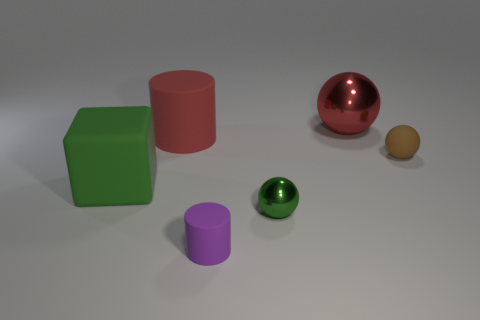There is a ball to the right of the large thing right of the tiny matte cylinder; what number of tiny brown matte spheres are right of it?
Make the answer very short. 0. What number of big metallic objects are the same shape as the purple matte object?
Provide a succinct answer. 0. There is a tiny thing that is behind the large block; is its color the same as the matte block?
Keep it short and to the point. No. There is a rubber object on the left side of the rubber cylinder that is behind the tiny matte cylinder in front of the big red matte cylinder; what is its shape?
Your answer should be very brief. Cube. There is a red shiny object; is its size the same as the matte cylinder behind the small matte cylinder?
Keep it short and to the point. Yes. Are there any blue cubes that have the same size as the green sphere?
Offer a terse response. No. How many other things are there of the same material as the purple thing?
Give a very brief answer. 3. There is a thing that is both on the right side of the tiny shiny thing and behind the small brown sphere; what is its color?
Ensure brevity in your answer.  Red. Is the material of the large thing right of the red rubber cylinder the same as the small thing that is right of the red metallic object?
Your answer should be compact. No. Is the size of the shiny sphere that is in front of the red matte thing the same as the green block?
Ensure brevity in your answer.  No. 